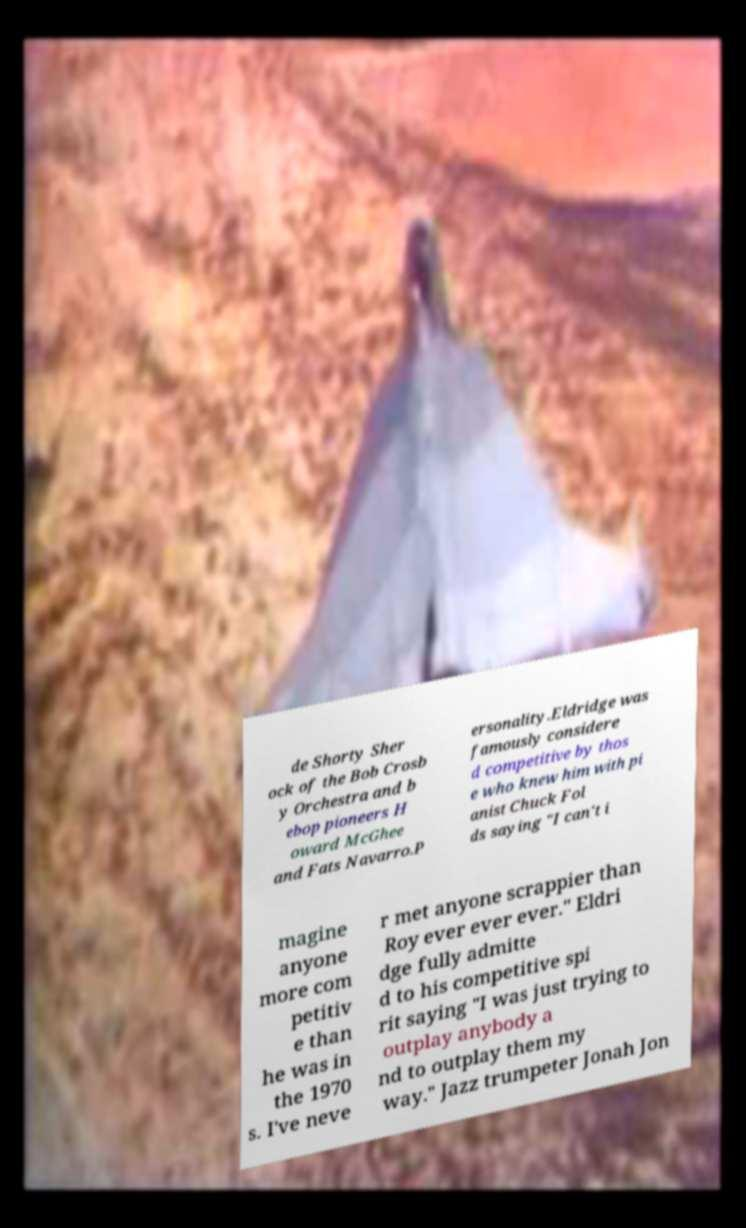Could you extract and type out the text from this image? de Shorty Sher ock of the Bob Crosb y Orchestra and b ebop pioneers H oward McGhee and Fats Navarro.P ersonality.Eldridge was famously considere d competitive by thos e who knew him with pi anist Chuck Fol ds saying "I can't i magine anyone more com petitiv e than he was in the 1970 s. I've neve r met anyone scrappier than Roy ever ever ever." Eldri dge fully admitte d to his competitive spi rit saying "I was just trying to outplay anybody a nd to outplay them my way." Jazz trumpeter Jonah Jon 